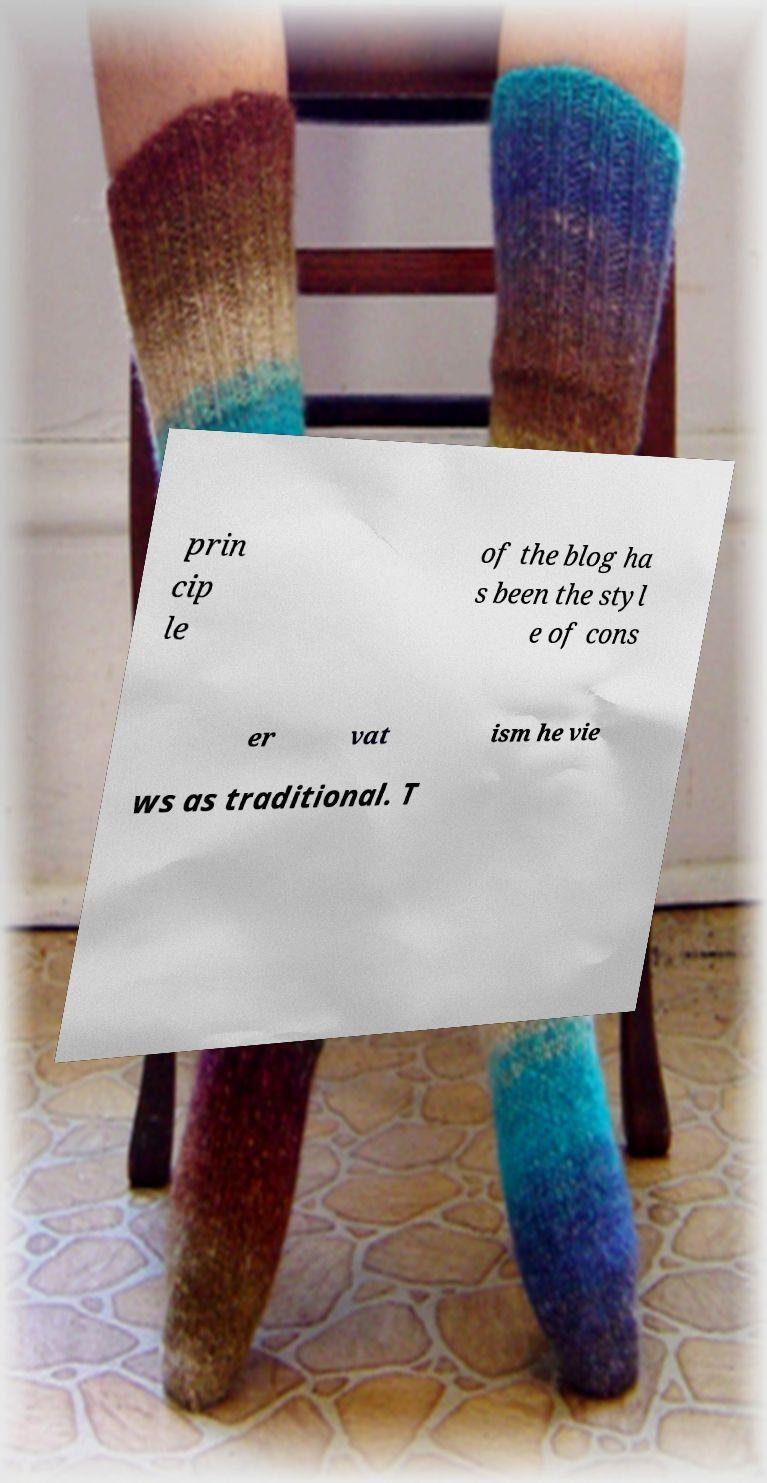For documentation purposes, I need the text within this image transcribed. Could you provide that? prin cip le of the blog ha s been the styl e of cons er vat ism he vie ws as traditional. T 